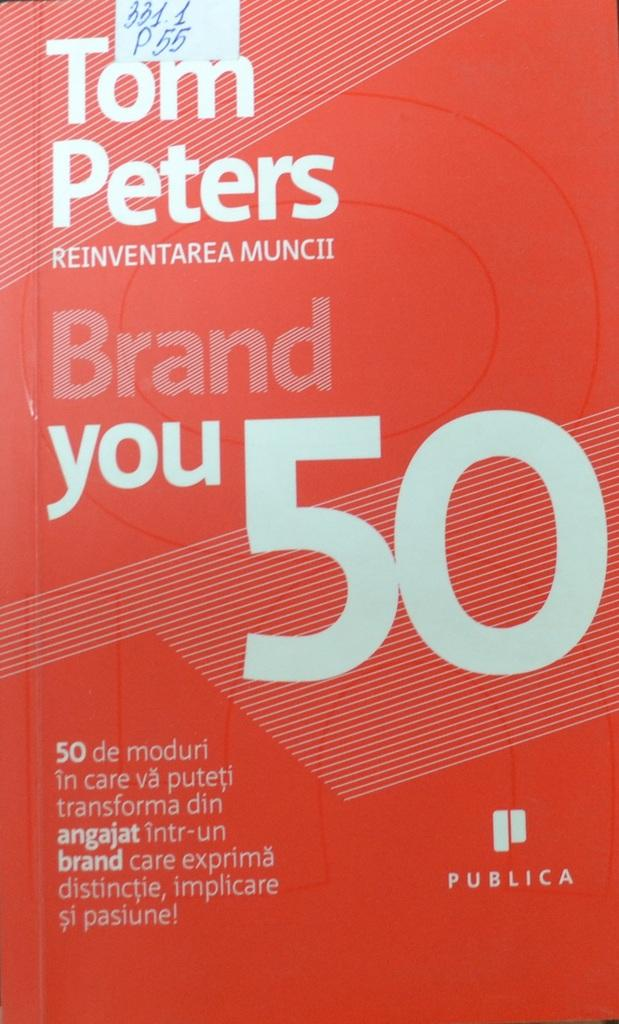<image>
Write a terse but informative summary of the picture. A red covered book titled Brand Your 50 